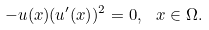<formula> <loc_0><loc_0><loc_500><loc_500>- u ( x ) ( u ^ { \prime } ( x ) ) ^ { 2 } = 0 , \ x \in \Omega .</formula> 